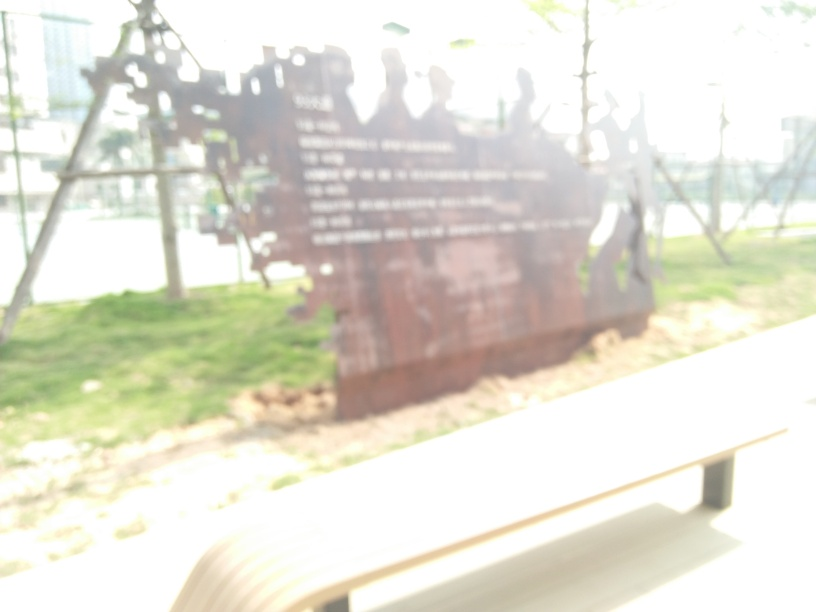Is the depth of field appropriate? The depth of field in the image appears to be less than ideal for clarity, as the image is quite blurry and details are hard to discern. This suggests a shallow depth of field where the focus isn't set correctly to capture the elements clearly. Optimal depth of field would allow the subject to be in sharp focus while providing a gradual transition to out-of-focus areas, creating a more aesthetically pleasing and informative image. 